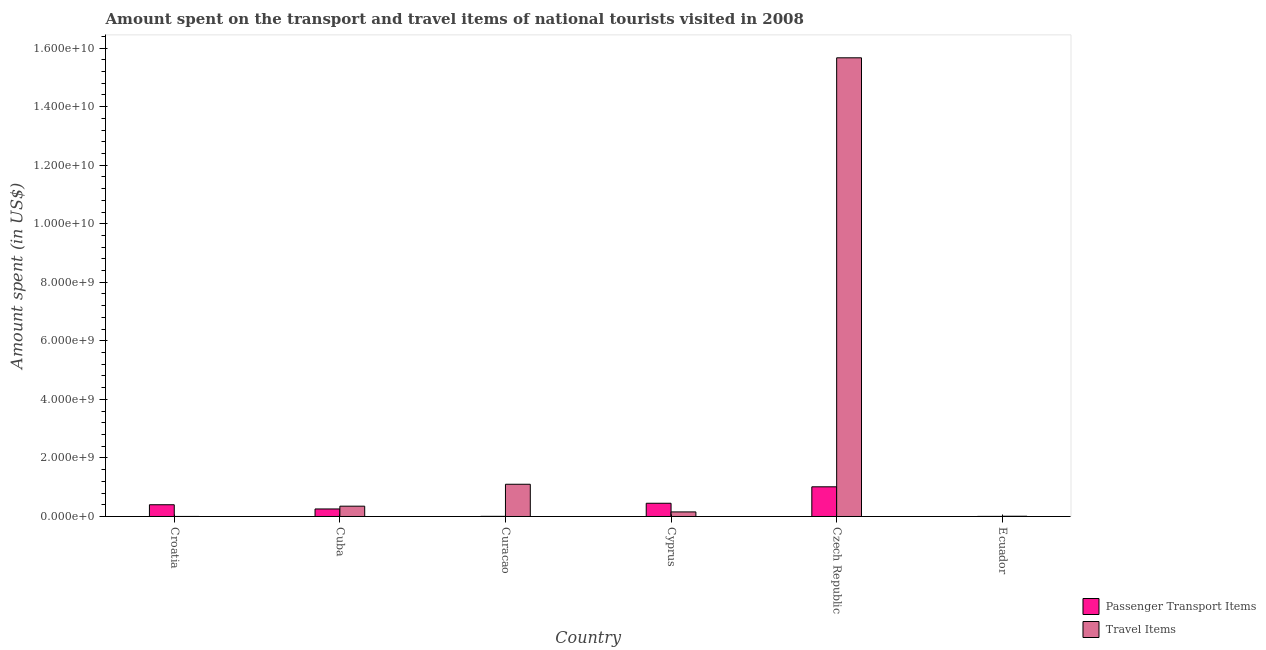Are the number of bars on each tick of the X-axis equal?
Give a very brief answer. Yes. How many bars are there on the 6th tick from the right?
Offer a terse response. 2. What is the label of the 3rd group of bars from the left?
Offer a terse response. Curacao. What is the amount spent on passenger transport items in Curacao?
Your response must be concise. 5.00e+06. Across all countries, what is the maximum amount spent on passenger transport items?
Your answer should be very brief. 1.01e+09. Across all countries, what is the minimum amount spent in travel items?
Offer a very short reply. 1.30e+06. In which country was the amount spent on passenger transport items maximum?
Your answer should be compact. Czech Republic. In which country was the amount spent on passenger transport items minimum?
Make the answer very short. Ecuador. What is the total amount spent on passenger transport items in the graph?
Give a very brief answer. 2.13e+09. What is the difference between the amount spent on passenger transport items in Cuba and that in Curacao?
Your answer should be compact. 2.52e+08. What is the difference between the amount spent in travel items in Curacao and the amount spent on passenger transport items in Czech Republic?
Your answer should be compact. 8.70e+07. What is the average amount spent on passenger transport items per country?
Provide a succinct answer. 3.55e+08. In how many countries, is the amount spent on passenger transport items greater than 12800000000 US$?
Make the answer very short. 0. What is the ratio of the amount spent in travel items in Croatia to that in Czech Republic?
Give a very brief answer. 8.297166198621394e-5. Is the amount spent in travel items in Cuba less than that in Czech Republic?
Your response must be concise. Yes. What is the difference between the highest and the second highest amount spent on passenger transport items?
Make the answer very short. 5.62e+08. What is the difference between the highest and the lowest amount spent on passenger transport items?
Ensure brevity in your answer.  1.01e+09. What does the 1st bar from the left in Ecuador represents?
Offer a very short reply. Passenger Transport Items. What does the 2nd bar from the right in Cuba represents?
Ensure brevity in your answer.  Passenger Transport Items. How many bars are there?
Offer a very short reply. 12. Are all the bars in the graph horizontal?
Offer a very short reply. No. How many countries are there in the graph?
Provide a short and direct response. 6. Does the graph contain grids?
Your answer should be very brief. No. Where does the legend appear in the graph?
Ensure brevity in your answer.  Bottom right. What is the title of the graph?
Your answer should be compact. Amount spent on the transport and travel items of national tourists visited in 2008. Does "Passenger Transport Items" appear as one of the legend labels in the graph?
Ensure brevity in your answer.  Yes. What is the label or title of the X-axis?
Keep it short and to the point. Country. What is the label or title of the Y-axis?
Make the answer very short. Amount spent (in US$). What is the Amount spent (in US$) in Passenger Transport Items in Croatia?
Your response must be concise. 4.01e+08. What is the Amount spent (in US$) of Travel Items in Croatia?
Keep it short and to the point. 1.30e+06. What is the Amount spent (in US$) of Passenger Transport Items in Cuba?
Ensure brevity in your answer.  2.57e+08. What is the Amount spent (in US$) in Travel Items in Cuba?
Offer a terse response. 3.52e+08. What is the Amount spent (in US$) in Travel Items in Curacao?
Make the answer very short. 1.10e+09. What is the Amount spent (in US$) of Passenger Transport Items in Cyprus?
Provide a succinct answer. 4.52e+08. What is the Amount spent (in US$) of Travel Items in Cyprus?
Give a very brief answer. 1.56e+08. What is the Amount spent (in US$) of Passenger Transport Items in Czech Republic?
Ensure brevity in your answer.  1.01e+09. What is the Amount spent (in US$) in Travel Items in Czech Republic?
Give a very brief answer. 1.57e+1. What is the Amount spent (in US$) of Passenger Transport Items in Ecuador?
Offer a very short reply. 3.00e+06. What is the Amount spent (in US$) of Travel Items in Ecuador?
Your answer should be very brief. 9.00e+06. Across all countries, what is the maximum Amount spent (in US$) of Passenger Transport Items?
Your answer should be very brief. 1.01e+09. Across all countries, what is the maximum Amount spent (in US$) of Travel Items?
Give a very brief answer. 1.57e+1. Across all countries, what is the minimum Amount spent (in US$) in Travel Items?
Offer a very short reply. 1.30e+06. What is the total Amount spent (in US$) of Passenger Transport Items in the graph?
Ensure brevity in your answer.  2.13e+09. What is the total Amount spent (in US$) in Travel Items in the graph?
Provide a succinct answer. 1.73e+1. What is the difference between the Amount spent (in US$) in Passenger Transport Items in Croatia and that in Cuba?
Provide a short and direct response. 1.44e+08. What is the difference between the Amount spent (in US$) of Travel Items in Croatia and that in Cuba?
Provide a succinct answer. -3.51e+08. What is the difference between the Amount spent (in US$) of Passenger Transport Items in Croatia and that in Curacao?
Your answer should be compact. 3.96e+08. What is the difference between the Amount spent (in US$) in Travel Items in Croatia and that in Curacao?
Provide a short and direct response. -1.10e+09. What is the difference between the Amount spent (in US$) in Passenger Transport Items in Croatia and that in Cyprus?
Offer a terse response. -5.10e+07. What is the difference between the Amount spent (in US$) of Travel Items in Croatia and that in Cyprus?
Your answer should be compact. -1.55e+08. What is the difference between the Amount spent (in US$) of Passenger Transport Items in Croatia and that in Czech Republic?
Your response must be concise. -6.13e+08. What is the difference between the Amount spent (in US$) in Travel Items in Croatia and that in Czech Republic?
Your response must be concise. -1.57e+1. What is the difference between the Amount spent (in US$) of Passenger Transport Items in Croatia and that in Ecuador?
Give a very brief answer. 3.98e+08. What is the difference between the Amount spent (in US$) of Travel Items in Croatia and that in Ecuador?
Your answer should be very brief. -7.70e+06. What is the difference between the Amount spent (in US$) of Passenger Transport Items in Cuba and that in Curacao?
Provide a succinct answer. 2.52e+08. What is the difference between the Amount spent (in US$) in Travel Items in Cuba and that in Curacao?
Make the answer very short. -7.49e+08. What is the difference between the Amount spent (in US$) in Passenger Transport Items in Cuba and that in Cyprus?
Keep it short and to the point. -1.95e+08. What is the difference between the Amount spent (in US$) of Travel Items in Cuba and that in Cyprus?
Your response must be concise. 1.96e+08. What is the difference between the Amount spent (in US$) in Passenger Transport Items in Cuba and that in Czech Republic?
Offer a terse response. -7.57e+08. What is the difference between the Amount spent (in US$) of Travel Items in Cuba and that in Czech Republic?
Make the answer very short. -1.53e+1. What is the difference between the Amount spent (in US$) in Passenger Transport Items in Cuba and that in Ecuador?
Offer a very short reply. 2.54e+08. What is the difference between the Amount spent (in US$) of Travel Items in Cuba and that in Ecuador?
Your response must be concise. 3.43e+08. What is the difference between the Amount spent (in US$) in Passenger Transport Items in Curacao and that in Cyprus?
Your answer should be compact. -4.47e+08. What is the difference between the Amount spent (in US$) in Travel Items in Curacao and that in Cyprus?
Offer a terse response. 9.45e+08. What is the difference between the Amount spent (in US$) in Passenger Transport Items in Curacao and that in Czech Republic?
Ensure brevity in your answer.  -1.01e+09. What is the difference between the Amount spent (in US$) in Travel Items in Curacao and that in Czech Republic?
Your answer should be compact. -1.46e+1. What is the difference between the Amount spent (in US$) in Travel Items in Curacao and that in Ecuador?
Offer a terse response. 1.09e+09. What is the difference between the Amount spent (in US$) of Passenger Transport Items in Cyprus and that in Czech Republic?
Offer a terse response. -5.62e+08. What is the difference between the Amount spent (in US$) of Travel Items in Cyprus and that in Czech Republic?
Your response must be concise. -1.55e+1. What is the difference between the Amount spent (in US$) of Passenger Transport Items in Cyprus and that in Ecuador?
Offer a terse response. 4.49e+08. What is the difference between the Amount spent (in US$) in Travel Items in Cyprus and that in Ecuador?
Ensure brevity in your answer.  1.47e+08. What is the difference between the Amount spent (in US$) in Passenger Transport Items in Czech Republic and that in Ecuador?
Ensure brevity in your answer.  1.01e+09. What is the difference between the Amount spent (in US$) in Travel Items in Czech Republic and that in Ecuador?
Your answer should be compact. 1.57e+1. What is the difference between the Amount spent (in US$) of Passenger Transport Items in Croatia and the Amount spent (in US$) of Travel Items in Cuba?
Offer a terse response. 4.90e+07. What is the difference between the Amount spent (in US$) of Passenger Transport Items in Croatia and the Amount spent (in US$) of Travel Items in Curacao?
Your answer should be very brief. -7.00e+08. What is the difference between the Amount spent (in US$) in Passenger Transport Items in Croatia and the Amount spent (in US$) in Travel Items in Cyprus?
Your response must be concise. 2.45e+08. What is the difference between the Amount spent (in US$) of Passenger Transport Items in Croatia and the Amount spent (in US$) of Travel Items in Czech Republic?
Keep it short and to the point. -1.53e+1. What is the difference between the Amount spent (in US$) of Passenger Transport Items in Croatia and the Amount spent (in US$) of Travel Items in Ecuador?
Offer a very short reply. 3.92e+08. What is the difference between the Amount spent (in US$) of Passenger Transport Items in Cuba and the Amount spent (in US$) of Travel Items in Curacao?
Keep it short and to the point. -8.44e+08. What is the difference between the Amount spent (in US$) in Passenger Transport Items in Cuba and the Amount spent (in US$) in Travel Items in Cyprus?
Offer a very short reply. 1.01e+08. What is the difference between the Amount spent (in US$) of Passenger Transport Items in Cuba and the Amount spent (in US$) of Travel Items in Czech Republic?
Offer a terse response. -1.54e+1. What is the difference between the Amount spent (in US$) in Passenger Transport Items in Cuba and the Amount spent (in US$) in Travel Items in Ecuador?
Keep it short and to the point. 2.48e+08. What is the difference between the Amount spent (in US$) of Passenger Transport Items in Curacao and the Amount spent (in US$) of Travel Items in Cyprus?
Your answer should be very brief. -1.51e+08. What is the difference between the Amount spent (in US$) in Passenger Transport Items in Curacao and the Amount spent (in US$) in Travel Items in Czech Republic?
Give a very brief answer. -1.57e+1. What is the difference between the Amount spent (in US$) in Passenger Transport Items in Cyprus and the Amount spent (in US$) in Travel Items in Czech Republic?
Give a very brief answer. -1.52e+1. What is the difference between the Amount spent (in US$) in Passenger Transport Items in Cyprus and the Amount spent (in US$) in Travel Items in Ecuador?
Your answer should be very brief. 4.43e+08. What is the difference between the Amount spent (in US$) of Passenger Transport Items in Czech Republic and the Amount spent (in US$) of Travel Items in Ecuador?
Keep it short and to the point. 1.00e+09. What is the average Amount spent (in US$) in Passenger Transport Items per country?
Your response must be concise. 3.55e+08. What is the average Amount spent (in US$) of Travel Items per country?
Your response must be concise. 2.88e+09. What is the difference between the Amount spent (in US$) in Passenger Transport Items and Amount spent (in US$) in Travel Items in Croatia?
Ensure brevity in your answer.  4.00e+08. What is the difference between the Amount spent (in US$) of Passenger Transport Items and Amount spent (in US$) of Travel Items in Cuba?
Your answer should be compact. -9.50e+07. What is the difference between the Amount spent (in US$) in Passenger Transport Items and Amount spent (in US$) in Travel Items in Curacao?
Your response must be concise. -1.10e+09. What is the difference between the Amount spent (in US$) in Passenger Transport Items and Amount spent (in US$) in Travel Items in Cyprus?
Give a very brief answer. 2.96e+08. What is the difference between the Amount spent (in US$) of Passenger Transport Items and Amount spent (in US$) of Travel Items in Czech Republic?
Give a very brief answer. -1.47e+1. What is the difference between the Amount spent (in US$) of Passenger Transport Items and Amount spent (in US$) of Travel Items in Ecuador?
Offer a terse response. -6.00e+06. What is the ratio of the Amount spent (in US$) in Passenger Transport Items in Croatia to that in Cuba?
Provide a succinct answer. 1.56. What is the ratio of the Amount spent (in US$) of Travel Items in Croatia to that in Cuba?
Keep it short and to the point. 0. What is the ratio of the Amount spent (in US$) in Passenger Transport Items in Croatia to that in Curacao?
Make the answer very short. 80.2. What is the ratio of the Amount spent (in US$) of Travel Items in Croatia to that in Curacao?
Offer a very short reply. 0. What is the ratio of the Amount spent (in US$) of Passenger Transport Items in Croatia to that in Cyprus?
Make the answer very short. 0.89. What is the ratio of the Amount spent (in US$) of Travel Items in Croatia to that in Cyprus?
Your answer should be compact. 0.01. What is the ratio of the Amount spent (in US$) in Passenger Transport Items in Croatia to that in Czech Republic?
Provide a short and direct response. 0.4. What is the ratio of the Amount spent (in US$) in Passenger Transport Items in Croatia to that in Ecuador?
Make the answer very short. 133.67. What is the ratio of the Amount spent (in US$) in Travel Items in Croatia to that in Ecuador?
Provide a short and direct response. 0.14. What is the ratio of the Amount spent (in US$) in Passenger Transport Items in Cuba to that in Curacao?
Ensure brevity in your answer.  51.4. What is the ratio of the Amount spent (in US$) in Travel Items in Cuba to that in Curacao?
Offer a very short reply. 0.32. What is the ratio of the Amount spent (in US$) in Passenger Transport Items in Cuba to that in Cyprus?
Offer a very short reply. 0.57. What is the ratio of the Amount spent (in US$) of Travel Items in Cuba to that in Cyprus?
Offer a very short reply. 2.26. What is the ratio of the Amount spent (in US$) in Passenger Transport Items in Cuba to that in Czech Republic?
Provide a succinct answer. 0.25. What is the ratio of the Amount spent (in US$) in Travel Items in Cuba to that in Czech Republic?
Your answer should be compact. 0.02. What is the ratio of the Amount spent (in US$) of Passenger Transport Items in Cuba to that in Ecuador?
Your answer should be compact. 85.67. What is the ratio of the Amount spent (in US$) in Travel Items in Cuba to that in Ecuador?
Offer a very short reply. 39.11. What is the ratio of the Amount spent (in US$) in Passenger Transport Items in Curacao to that in Cyprus?
Your response must be concise. 0.01. What is the ratio of the Amount spent (in US$) in Travel Items in Curacao to that in Cyprus?
Your answer should be very brief. 7.06. What is the ratio of the Amount spent (in US$) in Passenger Transport Items in Curacao to that in Czech Republic?
Offer a very short reply. 0. What is the ratio of the Amount spent (in US$) in Travel Items in Curacao to that in Czech Republic?
Provide a succinct answer. 0.07. What is the ratio of the Amount spent (in US$) of Travel Items in Curacao to that in Ecuador?
Provide a short and direct response. 122.33. What is the ratio of the Amount spent (in US$) of Passenger Transport Items in Cyprus to that in Czech Republic?
Make the answer very short. 0.45. What is the ratio of the Amount spent (in US$) in Passenger Transport Items in Cyprus to that in Ecuador?
Offer a terse response. 150.67. What is the ratio of the Amount spent (in US$) of Travel Items in Cyprus to that in Ecuador?
Ensure brevity in your answer.  17.33. What is the ratio of the Amount spent (in US$) in Passenger Transport Items in Czech Republic to that in Ecuador?
Your answer should be very brief. 338. What is the ratio of the Amount spent (in US$) of Travel Items in Czech Republic to that in Ecuador?
Make the answer very short. 1740.89. What is the difference between the highest and the second highest Amount spent (in US$) of Passenger Transport Items?
Your response must be concise. 5.62e+08. What is the difference between the highest and the second highest Amount spent (in US$) of Travel Items?
Make the answer very short. 1.46e+1. What is the difference between the highest and the lowest Amount spent (in US$) of Passenger Transport Items?
Your answer should be compact. 1.01e+09. What is the difference between the highest and the lowest Amount spent (in US$) of Travel Items?
Give a very brief answer. 1.57e+1. 